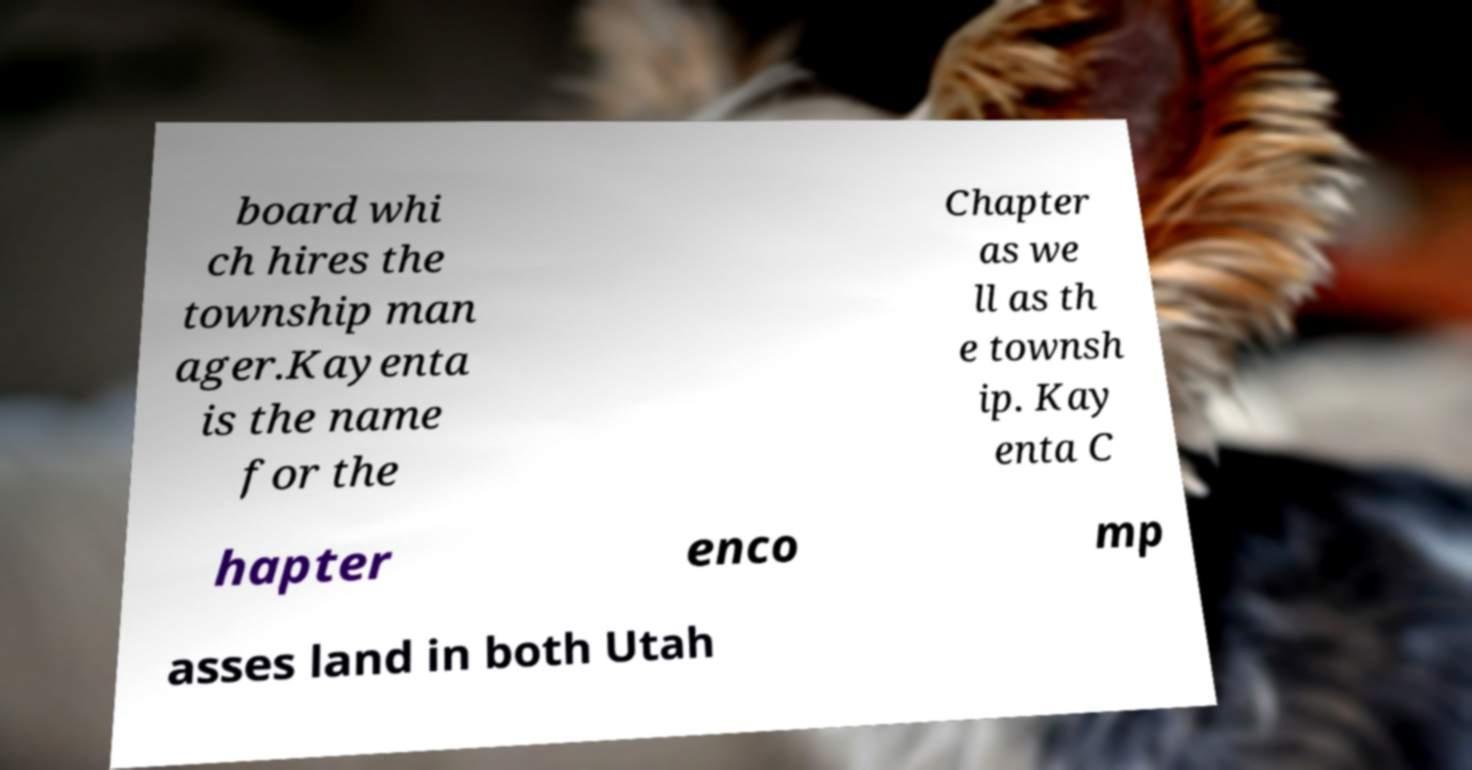Please identify and transcribe the text found in this image. board whi ch hires the township man ager.Kayenta is the name for the Chapter as we ll as th e townsh ip. Kay enta C hapter enco mp asses land in both Utah 